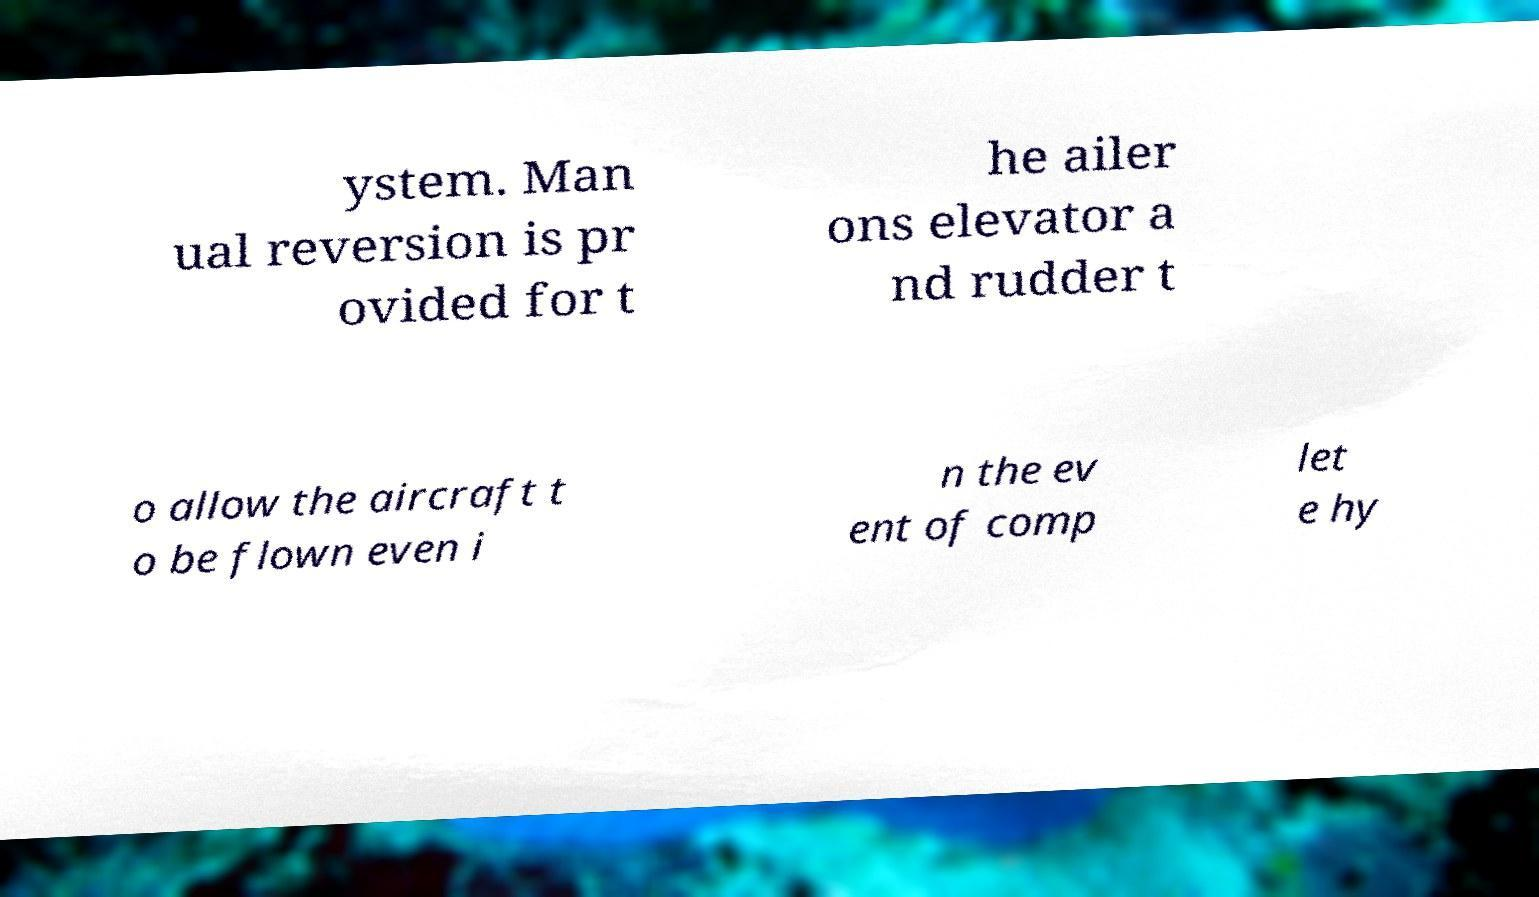Can you read and provide the text displayed in the image?This photo seems to have some interesting text. Can you extract and type it out for me? ystem. Man ual reversion is pr ovided for t he ailer ons elevator a nd rudder t o allow the aircraft t o be flown even i n the ev ent of comp let e hy 